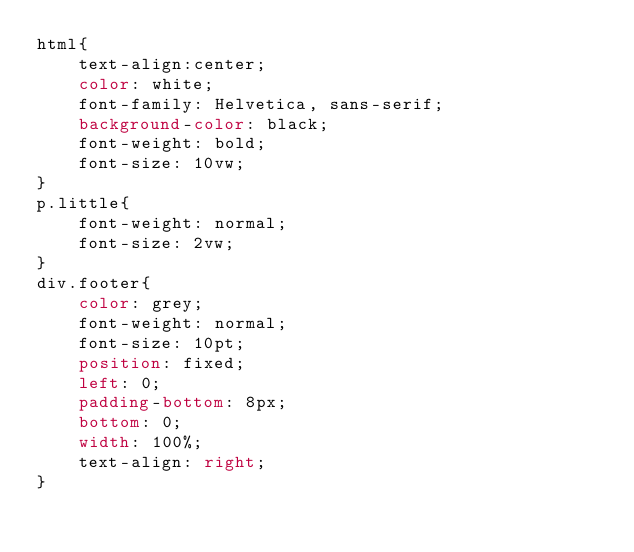Convert code to text. <code><loc_0><loc_0><loc_500><loc_500><_CSS_>html{
    text-align:center;
    color: white;
    font-family: Helvetica, sans-serif;
    background-color: black;
    font-weight: bold;
    font-size: 10vw;
}
p.little{
    font-weight: normal;
    font-size: 2vw;
}
div.footer{
    color: grey;
    font-weight: normal;
    font-size: 10pt;
    position: fixed;
    left: 0;
    padding-bottom: 8px;
    bottom: 0;
    width: 100%;
    text-align: right;
}</code> 